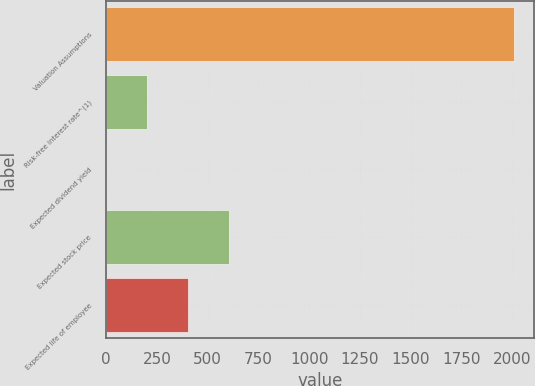<chart> <loc_0><loc_0><loc_500><loc_500><bar_chart><fcel>Valuation Assumptions<fcel>Risk-free interest rate^(1)<fcel>Expected dividend yield<fcel>Expected stock price<fcel>Expected life of employee<nl><fcel>2008<fcel>201.7<fcel>1<fcel>603.1<fcel>402.4<nl></chart> 